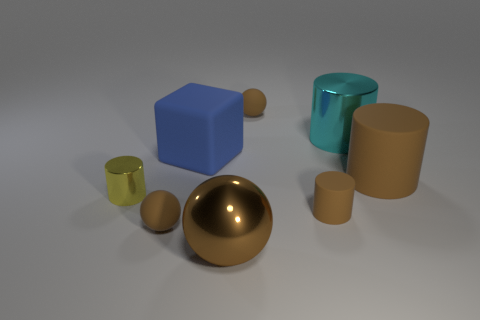There is a ball that is behind the large rubber block; what is it made of?
Your answer should be very brief. Rubber. What number of rubber things are behind the small yellow shiny object and on the left side of the big brown metal thing?
Your response must be concise. 1. There is a blue block that is the same size as the cyan thing; what is its material?
Your response must be concise. Rubber. Does the brown cylinder on the left side of the large metal cylinder have the same size as the brown cylinder behind the small yellow thing?
Your answer should be compact. No. There is a rubber block; are there any large cylinders on the left side of it?
Your response must be concise. No. There is a tiny ball in front of the tiny brown ball behind the big brown rubber thing; what color is it?
Your answer should be very brief. Brown. Is the number of tiny things less than the number of small blue matte objects?
Your answer should be very brief. No. How many small blue objects have the same shape as the cyan thing?
Offer a terse response. 0. There is a cube that is the same size as the brown metallic ball; what is its color?
Your response must be concise. Blue. Is the number of tiny brown spheres on the right side of the large blue rubber block the same as the number of tiny brown matte balls in front of the big shiny ball?
Offer a terse response. No. 